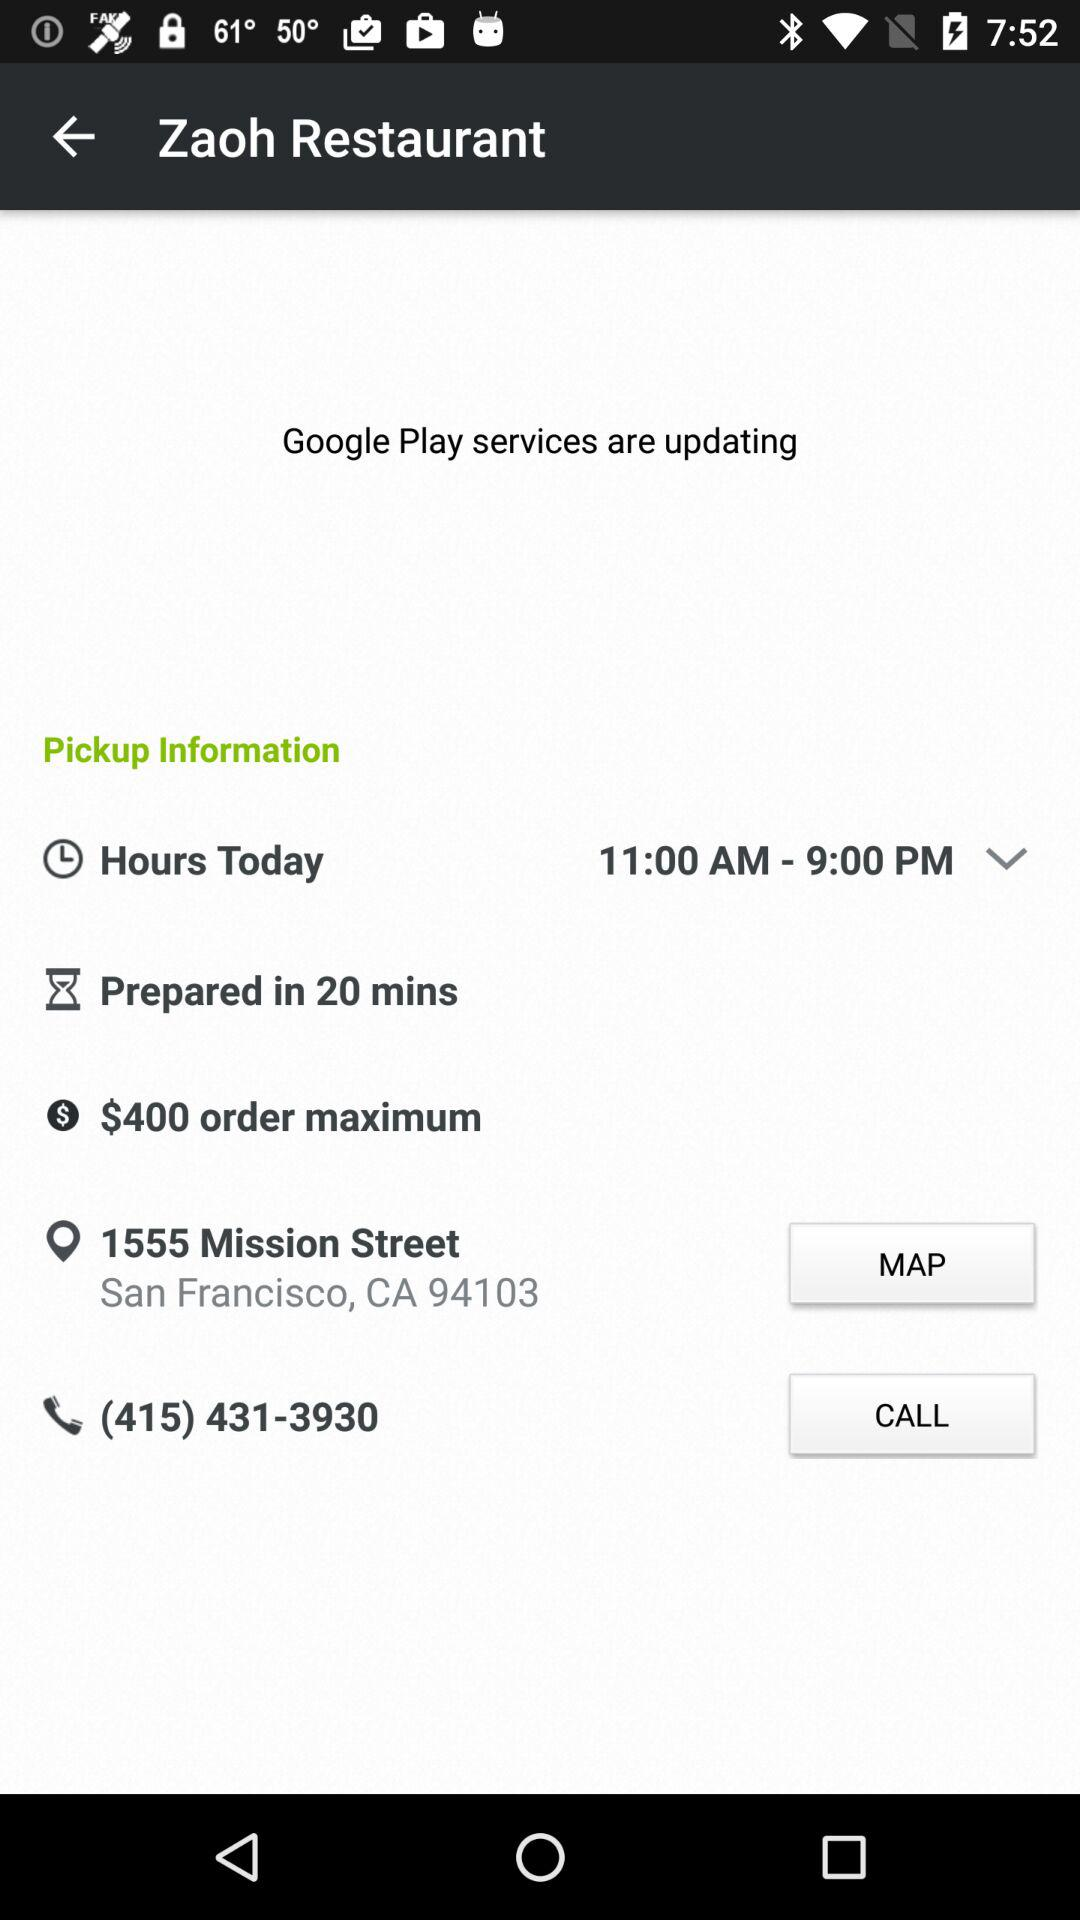What is the maximum order amount?
Answer the question using a single word or phrase. $400 